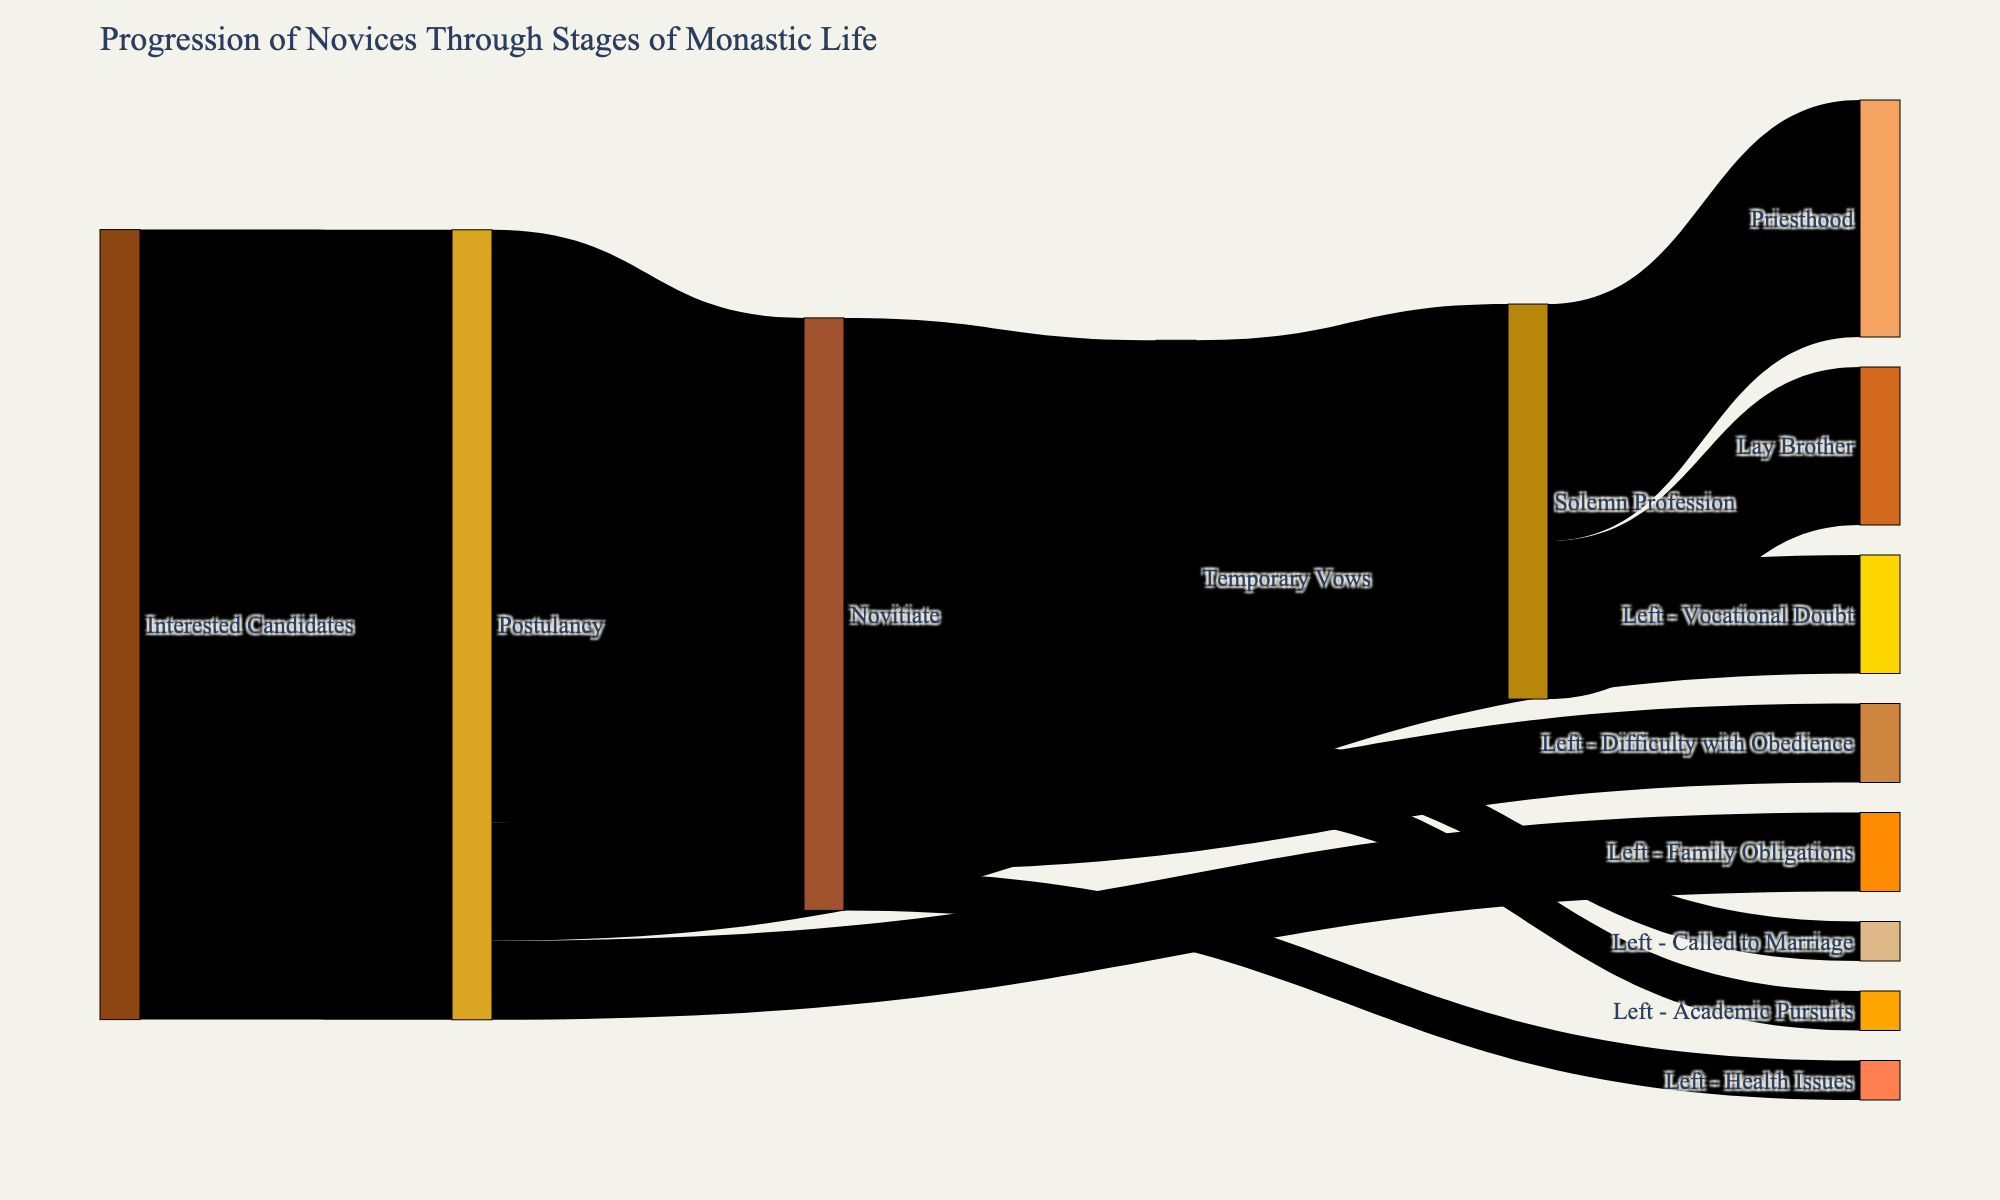What's the title of the diagram? Look at the top of the Sankey diagram where the title is usually placed. It says "Progression of Novices Through Stages of Monastic Life."
Answer: Progression of Novices Through Stages of Monastic Life How many candidates proceed from Postulancy to Novitiate? Examine the link between "Postulancy" and "Novitiate." The value associated here is 75.
Answer: 75 What is the total number of novices who left during the Postulancy stage? To find the total number of novices leaving at this stage, add the values associated with "Postulancy" leading to different departure reasons: 10 (Family Obligations) + 15 (Vocational Doubt) = 25.
Answer: 25 Which stage has the highest number of people progressing to the next stage? Compare the values at each transition point and identify the highest number. "Interested Candidates" to "Postulancy" has 100, which is the highest.
Answer: Interested Candidates to Postulancy How many novices moved from Temporary Vows to Solemn Profession? Look at the link between "Temporary Vows" and "Solemn Profession." The value is 50.
Answer: 50 What is the sum of novices who left during the Novitiate stage? Add the values of departures during the Novitiate stage: 5 (Health Issues) + 10 (Difficulty with Obedience) = 15.
Answer: 15 Which departure reason during the Temporary Vows stage had the same number of novices leaving as those who progressed to Lay Brother from Solemn Profession? "Temporary Vows" to "Called to Marriage" has 5 and "Solemn Profession" to "Lay Brother" has 20. They do not match, hence try the other link. "Temporary Vows" to "Academic Pursuits" has 5, which matches with "Called to Marriage."
Answer: Called to Marriage What is the overall number of novices who reached Solemn Profession? Combine the progressions to Solemn Profession from Temporary Vows and sum them up: The value of "Temporary Vows" to "Solemn Profession" is 50.
Answer: 50 Which stage-transition has the least number of novices? Observe the smallest value in the transitions. "Novitiate" to "Left - Health Issues" has the lowest value, which is 5.
Answer: Novitiate to Left - Health Issues How many novices eventually took priesthood after reaching Solemn Profession? Look at the value linking "Solemn Profession" to "Priesthood." It is 30.
Answer: 30 